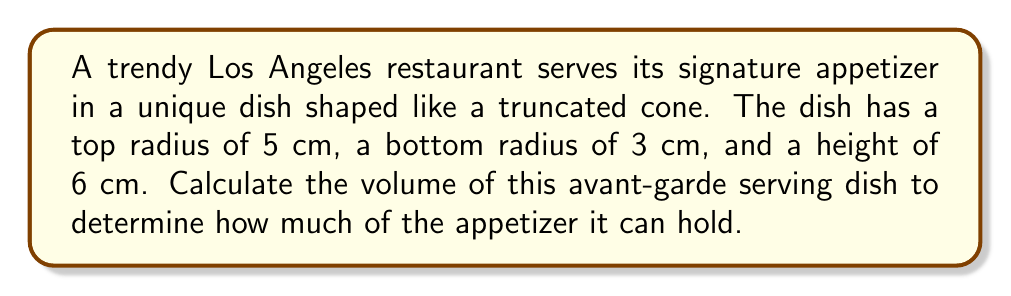Teach me how to tackle this problem. To calculate the volume of a truncated cone, we'll use the formula:

$$V = \frac{1}{3}\pi h(R^2 + r^2 + Rr)$$

Where:
$V$ = volume
$h$ = height
$R$ = radius of the larger base (top)
$r$ = radius of the smaller base (bottom)

Given:
$h = 6$ cm
$R = 5$ cm
$r = 3$ cm

Let's substitute these values into the formula:

$$V = \frac{1}{3}\pi \cdot 6(5^2 + 3^2 + 5 \cdot 3)$$

Simplify:
$$V = 2\pi(25 + 9 + 15)$$
$$V = 2\pi(49)$$
$$V = 98\pi$$

The exact volume is $98\pi$ cubic centimeters. If we want to approximate this:

$$V \approx 98 \cdot 3.14159 \approx 307.88 \text{ cm}^3$$

[asy]
import three;

size(200);
currentprojection=perspective(6,3,2);

real r1=3, r2=5, h=6;
triple A=(r1,0,0), B=(r2,0,h);

path3 p=A--B;
revolution s=revolution(p,Z);
draw(s,lightgray);
draw(circle((0,0,0),r1));
draw(circle((0,0,h),r2));
draw((0,0,0)--(0,0,h),dashed);
draw((r1,0,0)--(r2,0,h));
label("3 cm",(-r1,0,0),W);
label("5 cm",(-r2,0,h),W);
label("6 cm",(r2,0,h/2),E);
[/asy]
Answer: $98\pi \text{ cm}^3$ or approximately $307.88 \text{ cm}^3$ 